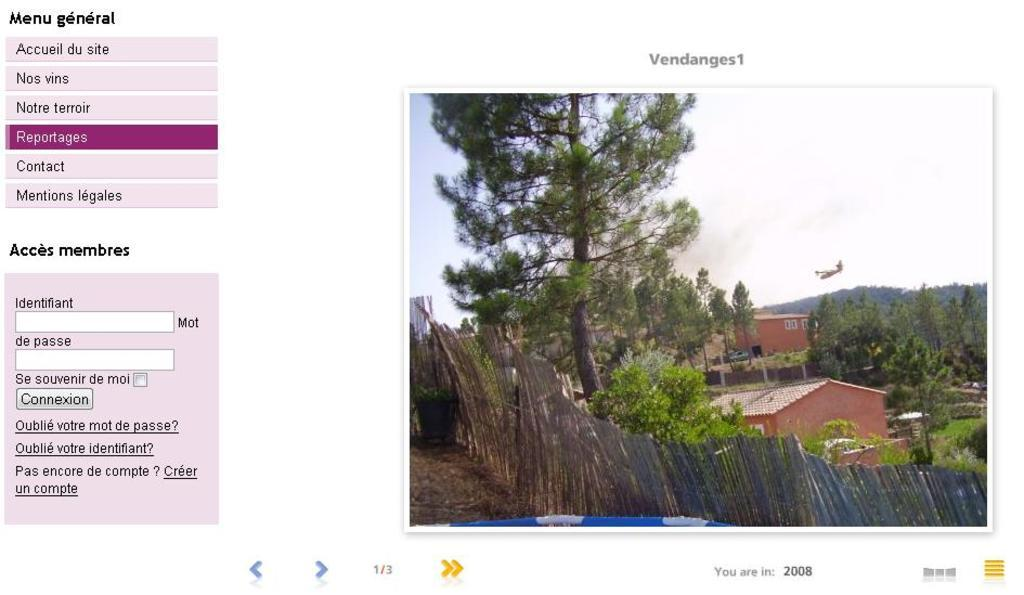What type of image is shown in the screenshot? The image is a screenshot. What can be seen in the screenshot? The screenshot contains a picture of houses and trees. Is there any additional information visible in the image? Yes, there is a menu visible in the image. What type of health advice can be found in the image? There is no health advice present in the image; it contains a picture of houses and trees, along with a menu. How many spots are visible on the trees in the image? There are no spots visible on the trees in the image; the trees appear to be healthy and without any visible spots or blemishes. 